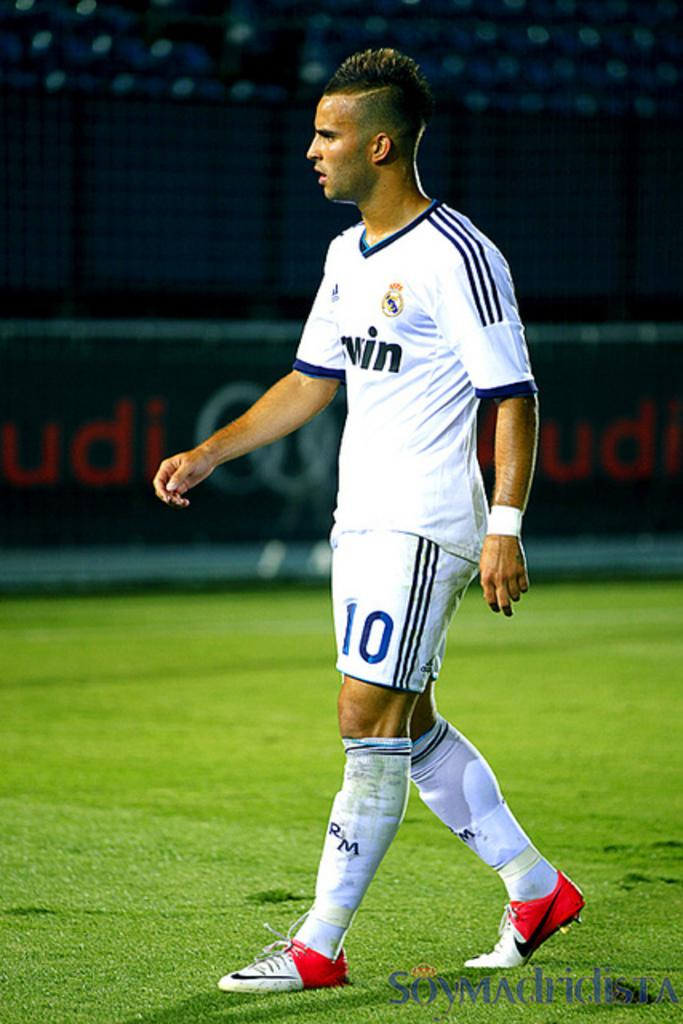What is the main subject of the image? There is a person standing in the image. Where is the person standing? The person is standing on the ground. What else can be seen in the image besides the person? There is a poster with text in the image. Where is the poster located in relation to the person? The poster is located behind the person. What type of soap is displayed on the poster in the image? There is no soap displayed on the poster in the image; it contains text. Can you tell me what kind of meat is being advertised on the poster? There is no meat being advertised on the poster; it contains text. 